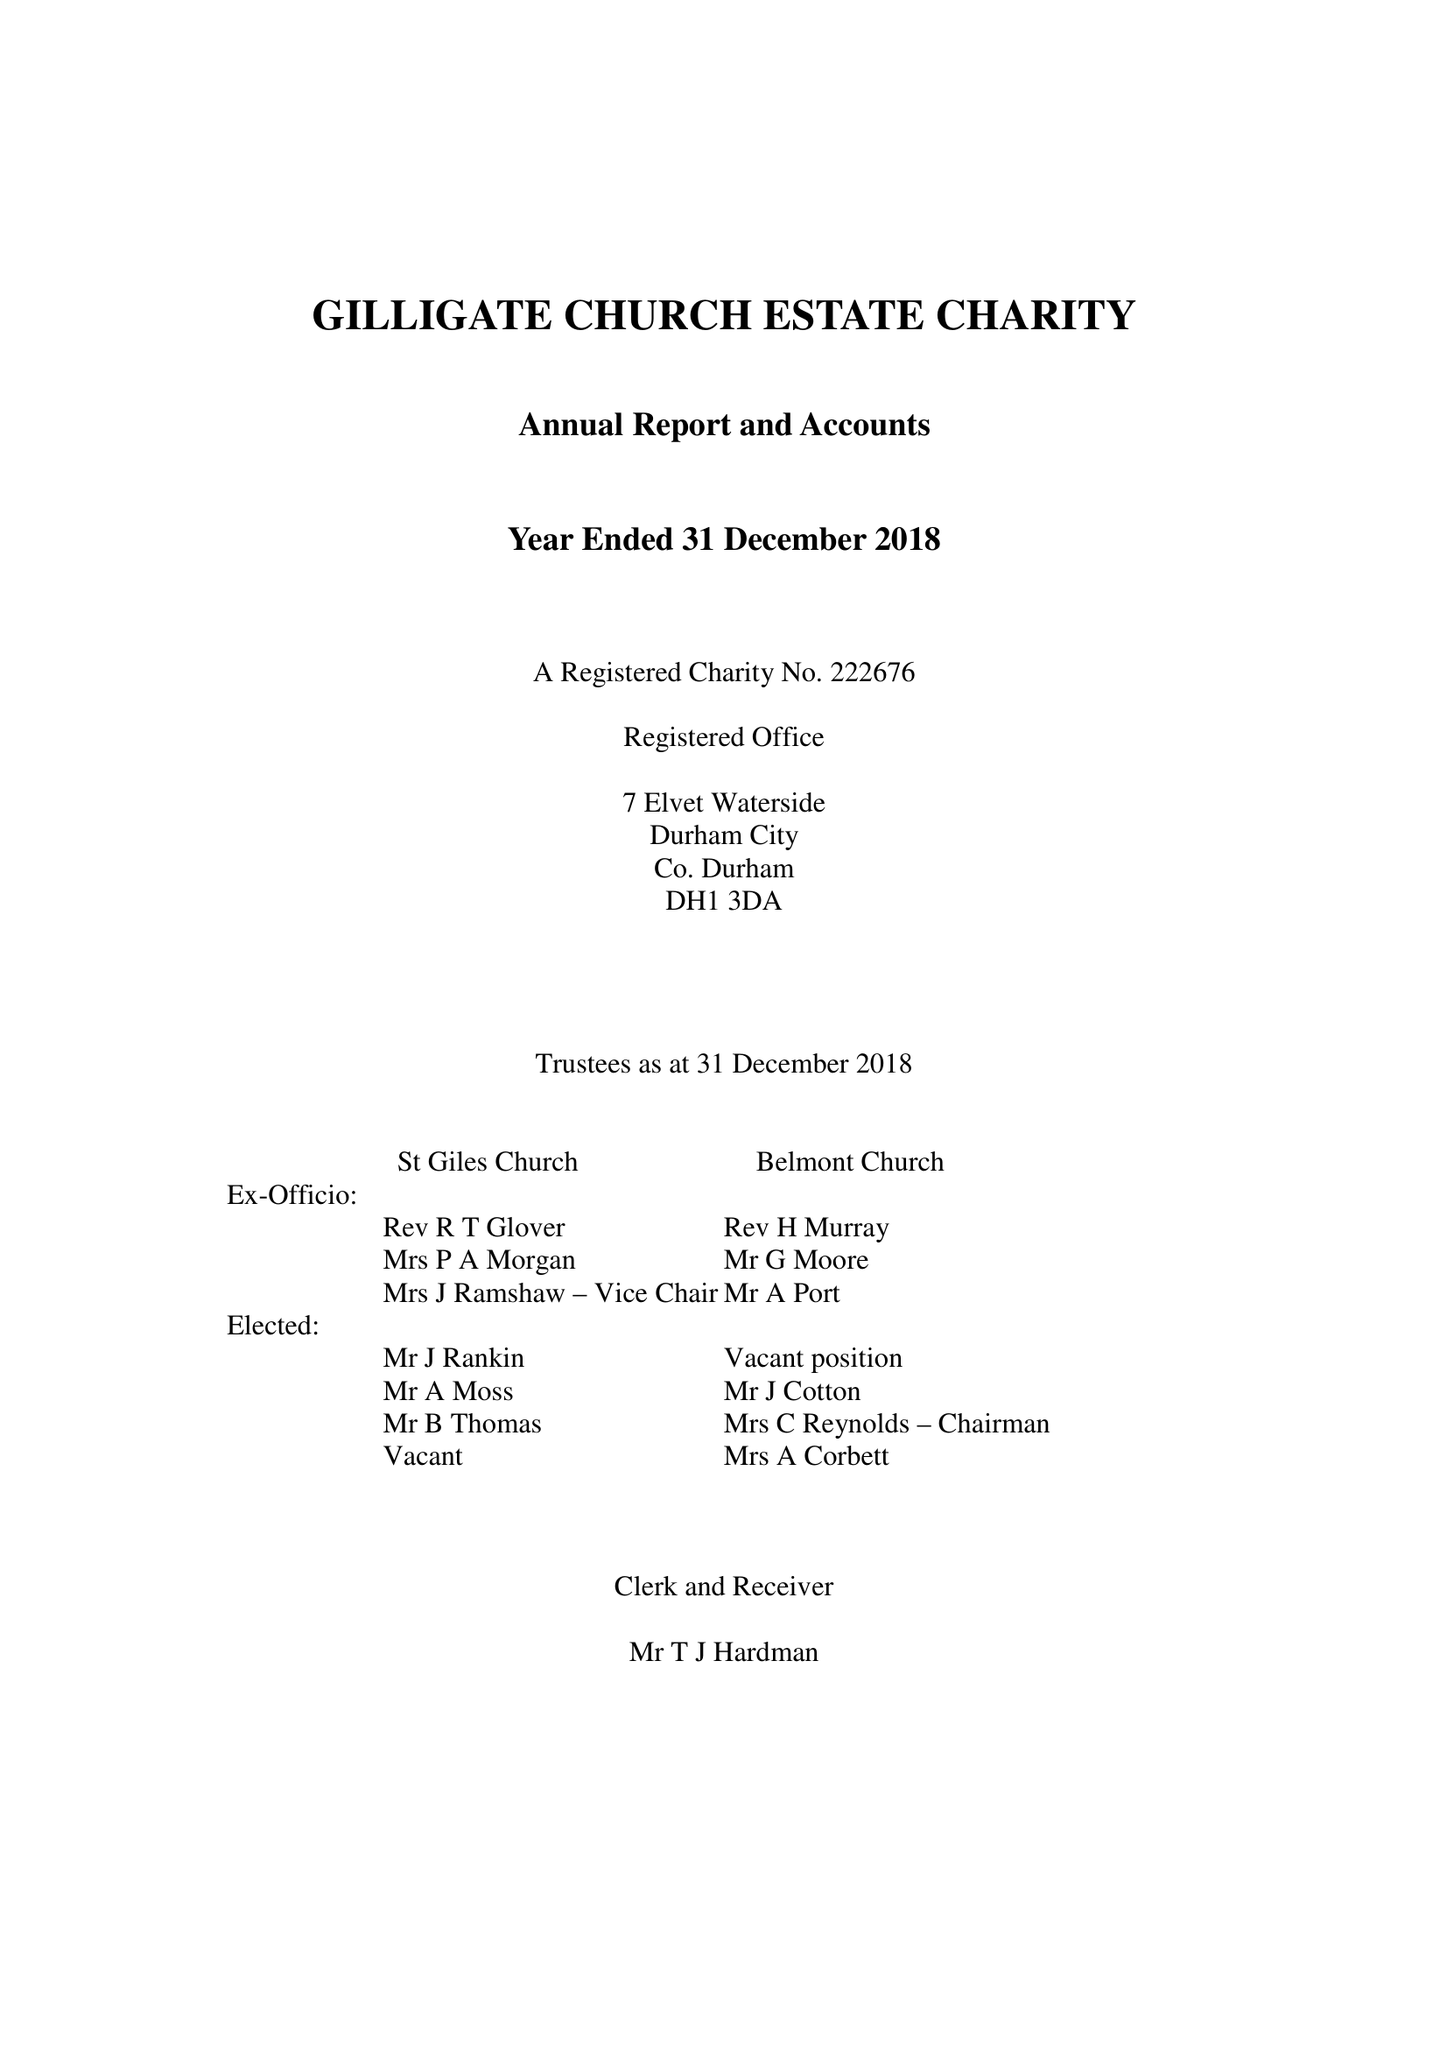What is the value for the charity_number?
Answer the question using a single word or phrase. 222676 